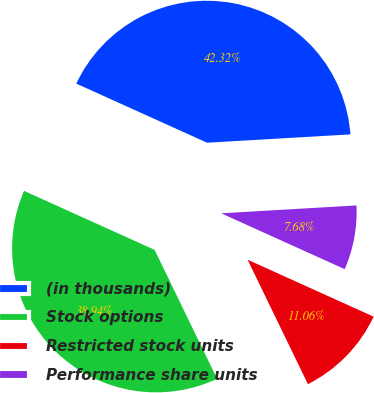Convert chart. <chart><loc_0><loc_0><loc_500><loc_500><pie_chart><fcel>(in thousands)<fcel>Stock options<fcel>Restricted stock units<fcel>Performance share units<nl><fcel>42.32%<fcel>38.94%<fcel>11.06%<fcel>7.68%<nl></chart> 